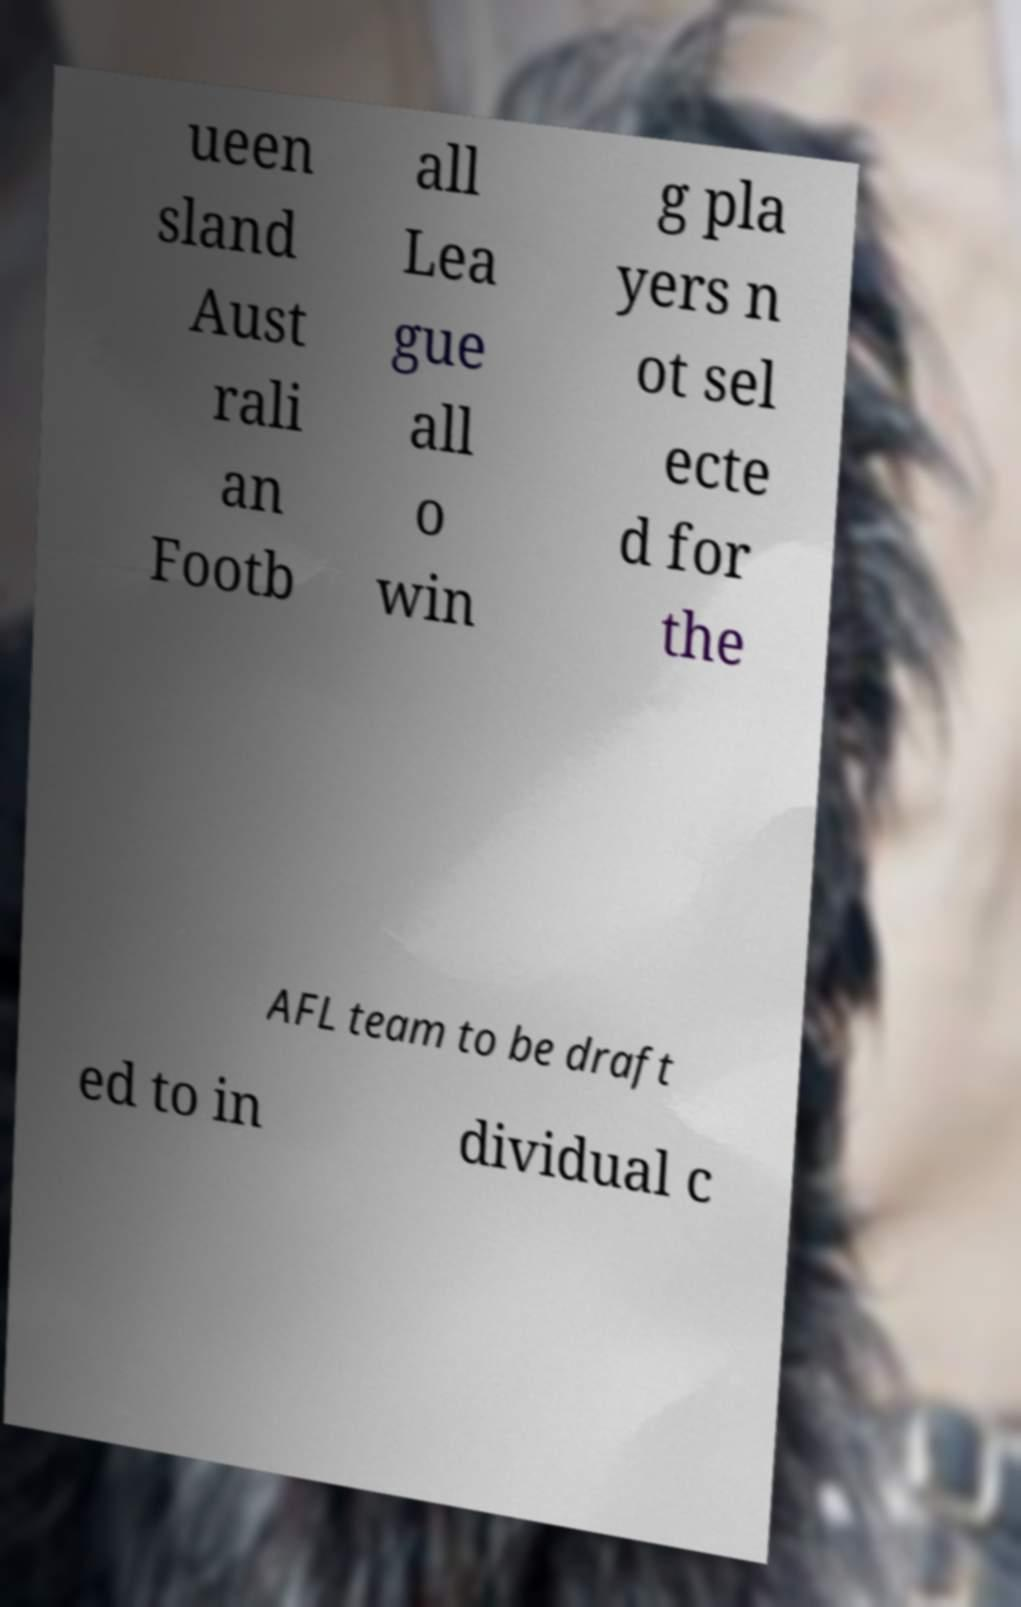Can you read and provide the text displayed in the image?This photo seems to have some interesting text. Can you extract and type it out for me? ueen sland Aust rali an Footb all Lea gue all o win g pla yers n ot sel ecte d for the AFL team to be draft ed to in dividual c 